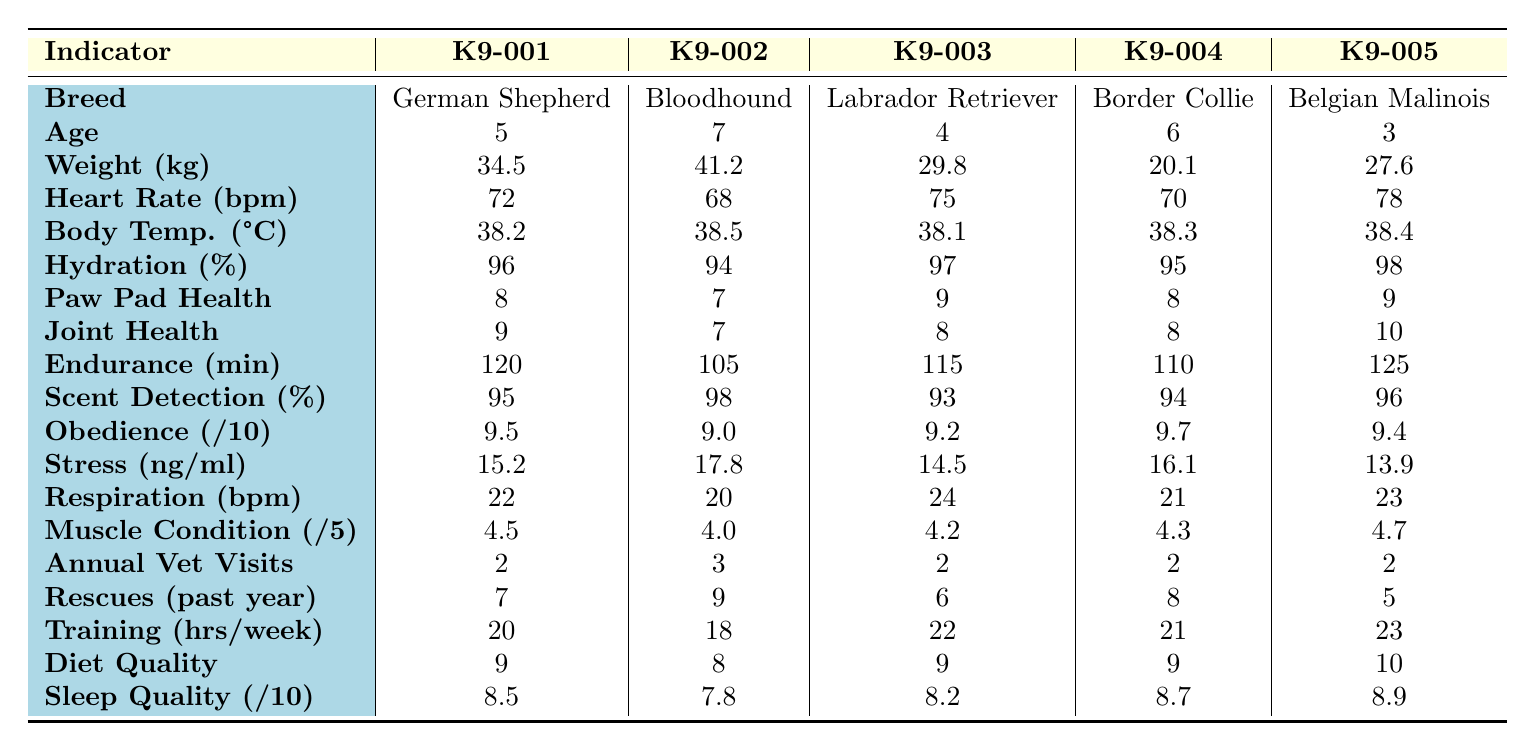What is the weight of K9-002? The table lists the weight of K9-002 as 41.2 kg.
Answer: 41.2 kg Which dog has the highest joint health score? By comparing the joint health scores, K9-005 has the highest score of 10.
Answer: K9-005 What is the average age of the dogs in the table? To find the average age, add the ages (5 + 7 + 4 + 6 + 3 = 25) and divide by 5. Thus, the average age is 25/5 = 5.
Answer: 5 Is K9-003 older than K9-001? K9-003 is 4 years old, and K9-001 is 5 years old, so K9-003 is not older.
Answer: No What is the difference in endurance time between K9-005 and K9-002? K9-005 has an endurance time of 125 minutes, and K9-002 has 105 minutes. The difference is 125 - 105 = 20 minutes.
Answer: 20 minutes Which dog has the lowest hydration level percentage? Comparing the hydration levels, K9-002 has the lowest at 94%.
Answer: K9-002 If you average the successful rescues of all dogs, what is the result? Summing the successful rescues (7 + 9 + 6 + 8 + 5 = 35) and dividing by 5 gives an average of 35/5 = 7.
Answer: 7 Which breed has the highest muscle condition score? K9-005, a Belgian Malinois, has the highest muscle condition score of 4.7.
Answer: K9-005 What is the average stress level across all five dogs? Adding the stress levels (15.2 + 17.8 + 14.5 + 16.1 + 13.9 = 77.5) and dividing by 5 gives an average of 77.5/5 = 15.5.
Answer: 15.5 Is the diet quality score for K9-004 higher than for K9-002? K9-004 has a diet quality score of 9, while K9-002 has 8, which means K9-004's score is higher.
Answer: Yes 